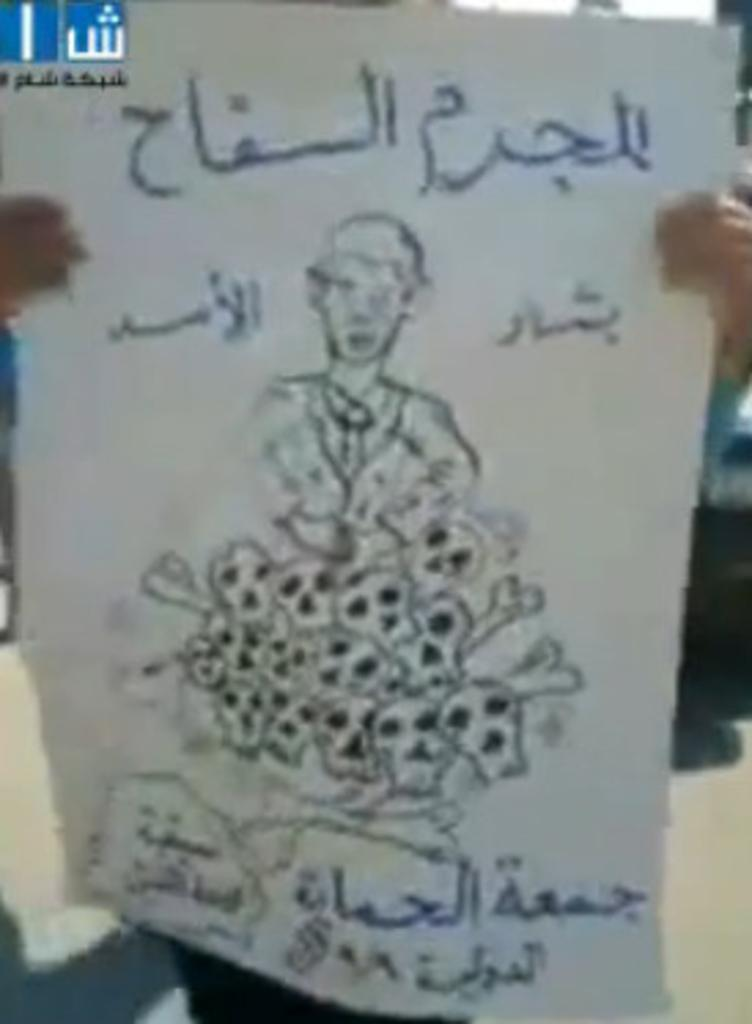What is depicted on the paper in the image? There is a drawing on the paper in the image. Is there any writing on the paper? Yes, there is text on the paper. What can be seen in the background of the image? There are objects in the background of the image. What type of suit is the sister wearing in the image? There is no sister or suit present in the image. How does the drawing stretch across the paper in the image? The drawing does not stretch across the paper in the image; it is a static image on the paper. 